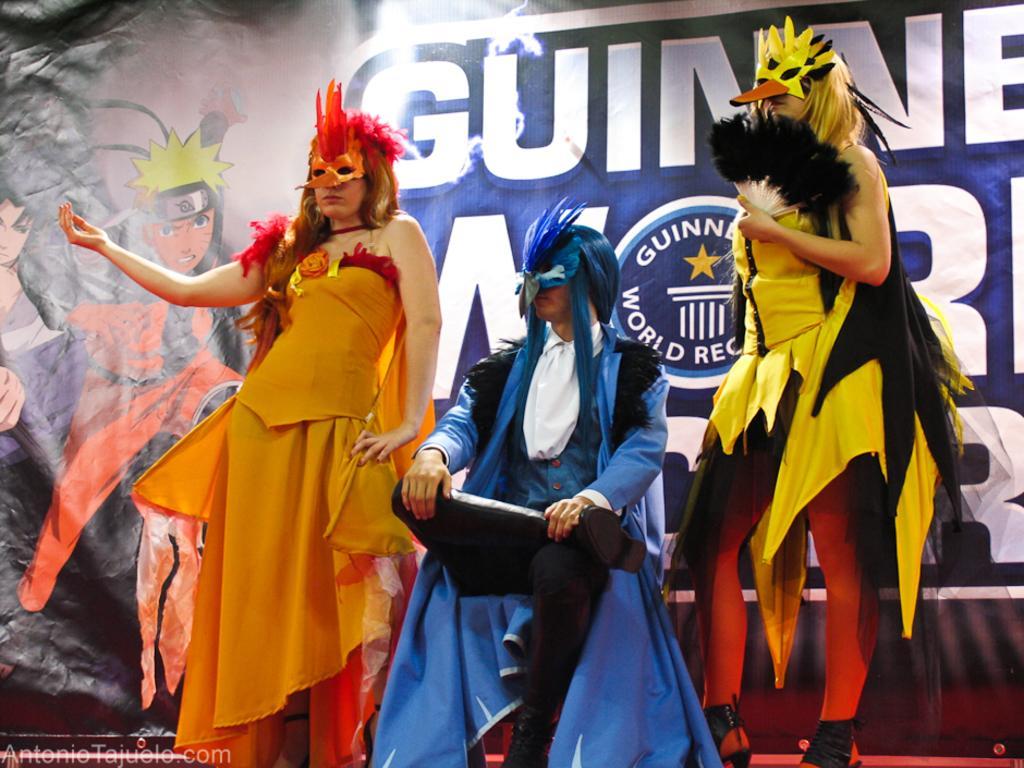Can you describe this image briefly? In this image we can see some persons. In the background of the image it looks like a board. On the image there is a watermark. 